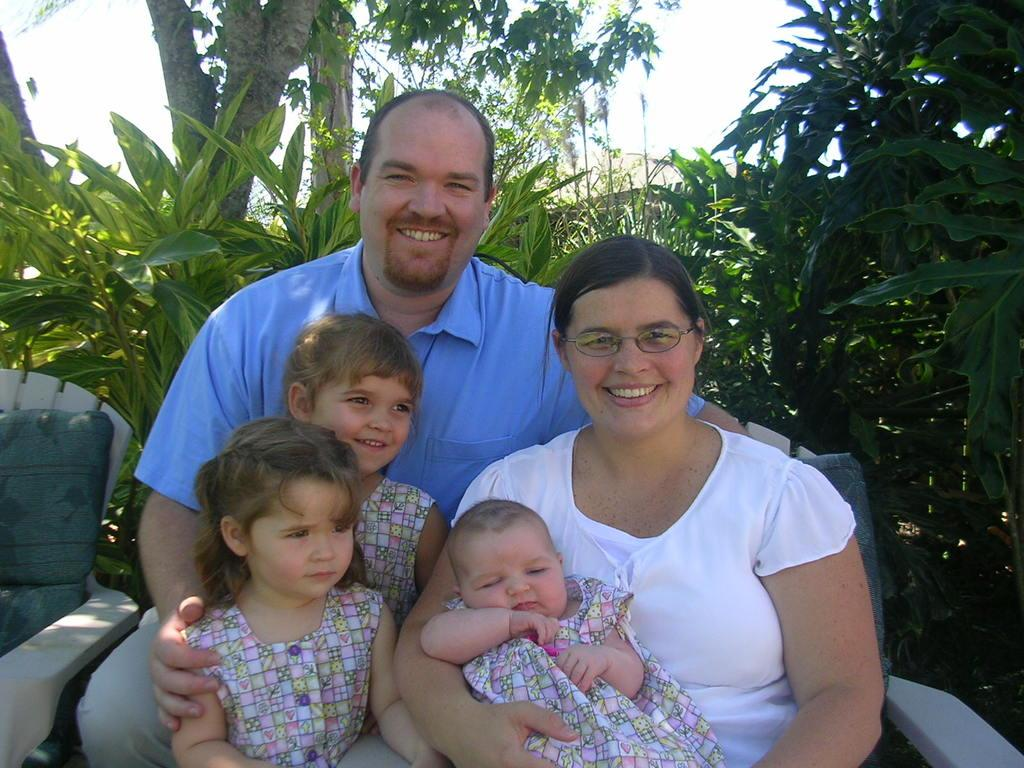What are the people in the image doing? The people in the image are sitting on chairs. Can you describe the position of the chair in the right corner of the image? There is a chair in the right corner of the image. What type of natural scenery can be seen in the image? Trees are visible in the image. What is visible in the background of the image? The sky is visible in the image. What type of neck accessory is the wren wearing in the image? There is no wren present in the image, so it is not possible to determine what type of neck accessory it might be wearing. 